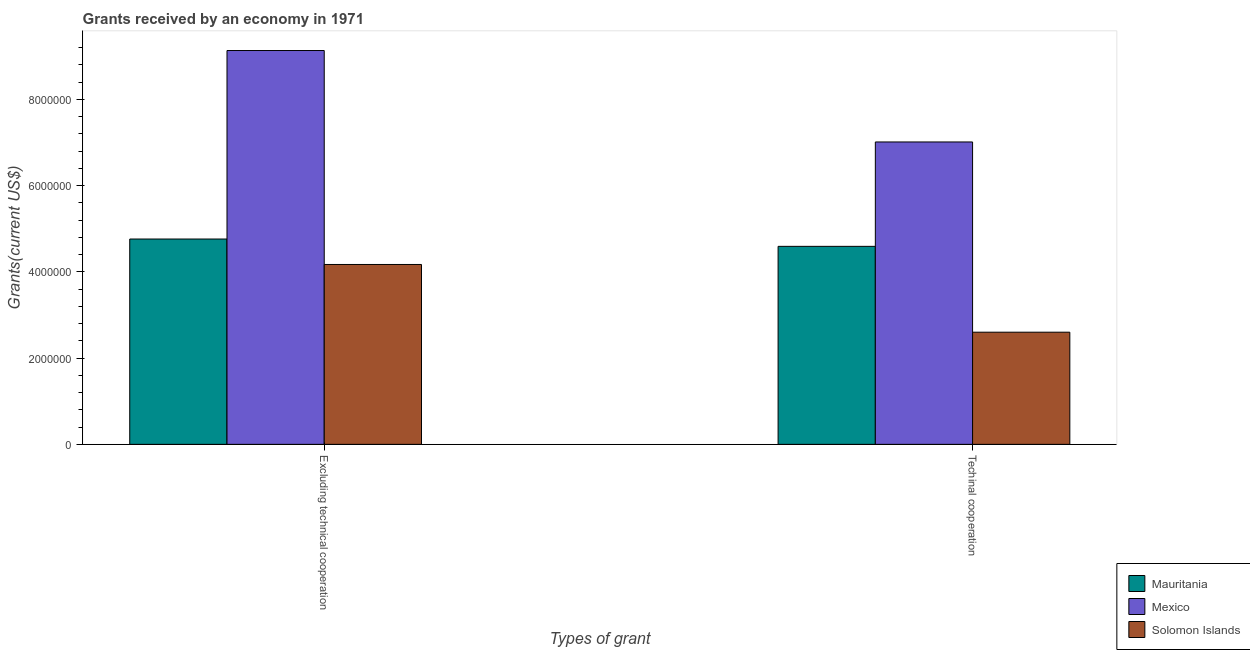How many different coloured bars are there?
Provide a short and direct response. 3. Are the number of bars per tick equal to the number of legend labels?
Make the answer very short. Yes. Are the number of bars on each tick of the X-axis equal?
Give a very brief answer. Yes. How many bars are there on the 2nd tick from the right?
Give a very brief answer. 3. What is the label of the 1st group of bars from the left?
Provide a succinct answer. Excluding technical cooperation. What is the amount of grants received(excluding technical cooperation) in Mexico?
Give a very brief answer. 9.13e+06. Across all countries, what is the maximum amount of grants received(excluding technical cooperation)?
Your answer should be compact. 9.13e+06. Across all countries, what is the minimum amount of grants received(excluding technical cooperation)?
Your answer should be very brief. 4.17e+06. In which country was the amount of grants received(excluding technical cooperation) minimum?
Offer a terse response. Solomon Islands. What is the total amount of grants received(excluding technical cooperation) in the graph?
Offer a terse response. 1.81e+07. What is the difference between the amount of grants received(including technical cooperation) in Mexico and that in Solomon Islands?
Your response must be concise. 4.41e+06. What is the difference between the amount of grants received(excluding technical cooperation) in Mexico and the amount of grants received(including technical cooperation) in Mauritania?
Provide a short and direct response. 4.54e+06. What is the average amount of grants received(excluding technical cooperation) per country?
Give a very brief answer. 6.02e+06. What is the difference between the amount of grants received(including technical cooperation) and amount of grants received(excluding technical cooperation) in Mexico?
Offer a very short reply. -2.12e+06. In how many countries, is the amount of grants received(including technical cooperation) greater than 400000 US$?
Your response must be concise. 3. What is the ratio of the amount of grants received(excluding technical cooperation) in Solomon Islands to that in Mexico?
Give a very brief answer. 0.46. In how many countries, is the amount of grants received(excluding technical cooperation) greater than the average amount of grants received(excluding technical cooperation) taken over all countries?
Your response must be concise. 1. What does the 1st bar from the left in Excluding technical cooperation represents?
Offer a terse response. Mauritania. What does the 1st bar from the right in Excluding technical cooperation represents?
Offer a terse response. Solomon Islands. Are all the bars in the graph horizontal?
Provide a succinct answer. No. How many countries are there in the graph?
Offer a terse response. 3. What is the difference between two consecutive major ticks on the Y-axis?
Your answer should be compact. 2.00e+06. Are the values on the major ticks of Y-axis written in scientific E-notation?
Offer a terse response. No. How are the legend labels stacked?
Offer a very short reply. Vertical. What is the title of the graph?
Provide a succinct answer. Grants received by an economy in 1971. What is the label or title of the X-axis?
Your answer should be very brief. Types of grant. What is the label or title of the Y-axis?
Keep it short and to the point. Grants(current US$). What is the Grants(current US$) in Mauritania in Excluding technical cooperation?
Give a very brief answer. 4.76e+06. What is the Grants(current US$) in Mexico in Excluding technical cooperation?
Provide a short and direct response. 9.13e+06. What is the Grants(current US$) of Solomon Islands in Excluding technical cooperation?
Ensure brevity in your answer.  4.17e+06. What is the Grants(current US$) of Mauritania in Techinal cooperation?
Give a very brief answer. 4.59e+06. What is the Grants(current US$) of Mexico in Techinal cooperation?
Provide a succinct answer. 7.01e+06. What is the Grants(current US$) of Solomon Islands in Techinal cooperation?
Keep it short and to the point. 2.60e+06. Across all Types of grant, what is the maximum Grants(current US$) in Mauritania?
Your answer should be compact. 4.76e+06. Across all Types of grant, what is the maximum Grants(current US$) of Mexico?
Your answer should be compact. 9.13e+06. Across all Types of grant, what is the maximum Grants(current US$) in Solomon Islands?
Your answer should be very brief. 4.17e+06. Across all Types of grant, what is the minimum Grants(current US$) in Mauritania?
Your answer should be very brief. 4.59e+06. Across all Types of grant, what is the minimum Grants(current US$) in Mexico?
Keep it short and to the point. 7.01e+06. Across all Types of grant, what is the minimum Grants(current US$) of Solomon Islands?
Give a very brief answer. 2.60e+06. What is the total Grants(current US$) of Mauritania in the graph?
Your response must be concise. 9.35e+06. What is the total Grants(current US$) of Mexico in the graph?
Provide a succinct answer. 1.61e+07. What is the total Grants(current US$) of Solomon Islands in the graph?
Your answer should be compact. 6.77e+06. What is the difference between the Grants(current US$) in Mexico in Excluding technical cooperation and that in Techinal cooperation?
Your response must be concise. 2.12e+06. What is the difference between the Grants(current US$) of Solomon Islands in Excluding technical cooperation and that in Techinal cooperation?
Provide a succinct answer. 1.57e+06. What is the difference between the Grants(current US$) of Mauritania in Excluding technical cooperation and the Grants(current US$) of Mexico in Techinal cooperation?
Offer a terse response. -2.25e+06. What is the difference between the Grants(current US$) of Mauritania in Excluding technical cooperation and the Grants(current US$) of Solomon Islands in Techinal cooperation?
Ensure brevity in your answer.  2.16e+06. What is the difference between the Grants(current US$) in Mexico in Excluding technical cooperation and the Grants(current US$) in Solomon Islands in Techinal cooperation?
Provide a succinct answer. 6.53e+06. What is the average Grants(current US$) in Mauritania per Types of grant?
Make the answer very short. 4.68e+06. What is the average Grants(current US$) of Mexico per Types of grant?
Offer a terse response. 8.07e+06. What is the average Grants(current US$) of Solomon Islands per Types of grant?
Offer a very short reply. 3.38e+06. What is the difference between the Grants(current US$) of Mauritania and Grants(current US$) of Mexico in Excluding technical cooperation?
Your response must be concise. -4.37e+06. What is the difference between the Grants(current US$) of Mauritania and Grants(current US$) of Solomon Islands in Excluding technical cooperation?
Your answer should be compact. 5.90e+05. What is the difference between the Grants(current US$) in Mexico and Grants(current US$) in Solomon Islands in Excluding technical cooperation?
Offer a terse response. 4.96e+06. What is the difference between the Grants(current US$) in Mauritania and Grants(current US$) in Mexico in Techinal cooperation?
Keep it short and to the point. -2.42e+06. What is the difference between the Grants(current US$) of Mauritania and Grants(current US$) of Solomon Islands in Techinal cooperation?
Your answer should be compact. 1.99e+06. What is the difference between the Grants(current US$) of Mexico and Grants(current US$) of Solomon Islands in Techinal cooperation?
Your answer should be very brief. 4.41e+06. What is the ratio of the Grants(current US$) of Mexico in Excluding technical cooperation to that in Techinal cooperation?
Your response must be concise. 1.3. What is the ratio of the Grants(current US$) in Solomon Islands in Excluding technical cooperation to that in Techinal cooperation?
Offer a very short reply. 1.6. What is the difference between the highest and the second highest Grants(current US$) of Mexico?
Offer a very short reply. 2.12e+06. What is the difference between the highest and the second highest Grants(current US$) in Solomon Islands?
Your answer should be very brief. 1.57e+06. What is the difference between the highest and the lowest Grants(current US$) in Mexico?
Offer a very short reply. 2.12e+06. What is the difference between the highest and the lowest Grants(current US$) in Solomon Islands?
Ensure brevity in your answer.  1.57e+06. 